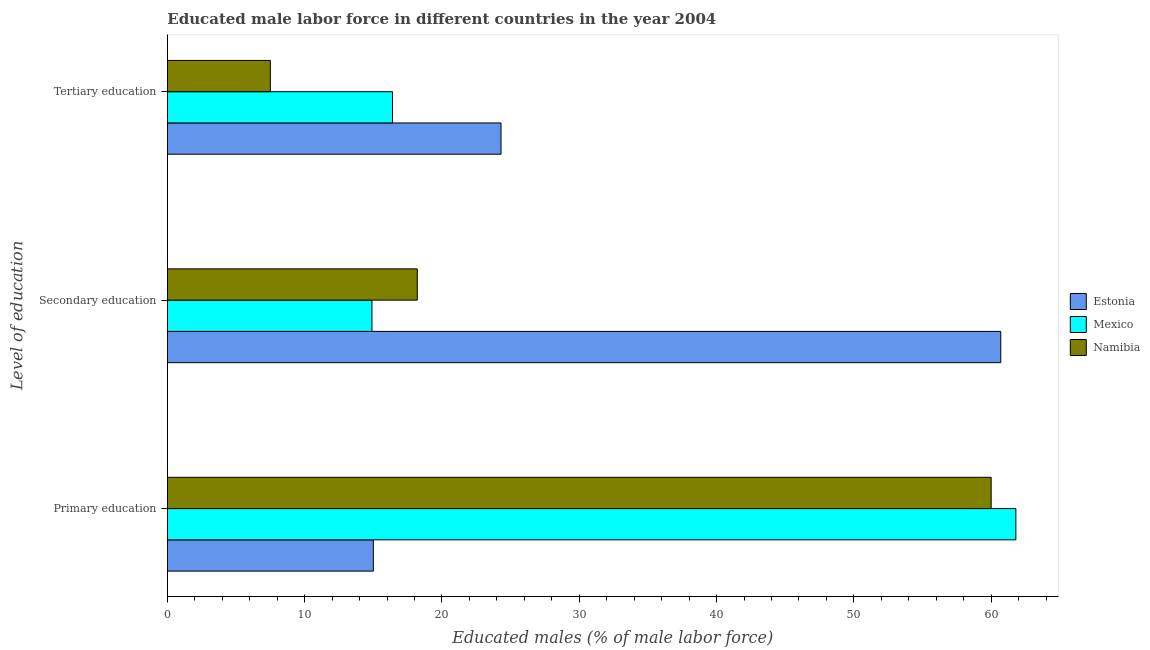Are the number of bars on each tick of the Y-axis equal?
Ensure brevity in your answer.  Yes. How many bars are there on the 3rd tick from the top?
Keep it short and to the point. 3. How many bars are there on the 1st tick from the bottom?
Offer a very short reply. 3. What is the label of the 1st group of bars from the top?
Give a very brief answer. Tertiary education. What is the percentage of male labor force who received secondary education in Estonia?
Make the answer very short. 60.7. Across all countries, what is the maximum percentage of male labor force who received tertiary education?
Offer a very short reply. 24.3. Across all countries, what is the minimum percentage of male labor force who received tertiary education?
Make the answer very short. 7.5. In which country was the percentage of male labor force who received tertiary education maximum?
Your answer should be compact. Estonia. In which country was the percentage of male labor force who received secondary education minimum?
Your answer should be compact. Mexico. What is the total percentage of male labor force who received tertiary education in the graph?
Ensure brevity in your answer.  48.2. What is the difference between the percentage of male labor force who received tertiary education in Estonia and that in Mexico?
Your response must be concise. 7.9. What is the difference between the percentage of male labor force who received primary education in Mexico and the percentage of male labor force who received tertiary education in Namibia?
Keep it short and to the point. 54.3. What is the average percentage of male labor force who received secondary education per country?
Give a very brief answer. 31.27. What is the difference between the percentage of male labor force who received tertiary education and percentage of male labor force who received secondary education in Namibia?
Your answer should be compact. -10.7. Is the percentage of male labor force who received primary education in Namibia less than that in Estonia?
Provide a short and direct response. No. Is the difference between the percentage of male labor force who received tertiary education in Mexico and Namibia greater than the difference between the percentage of male labor force who received primary education in Mexico and Namibia?
Offer a terse response. Yes. What is the difference between the highest and the second highest percentage of male labor force who received tertiary education?
Offer a terse response. 7.9. What is the difference between the highest and the lowest percentage of male labor force who received primary education?
Your answer should be very brief. 46.8. In how many countries, is the percentage of male labor force who received secondary education greater than the average percentage of male labor force who received secondary education taken over all countries?
Your answer should be very brief. 1. Is the sum of the percentage of male labor force who received primary education in Mexico and Estonia greater than the maximum percentage of male labor force who received secondary education across all countries?
Offer a very short reply. Yes. What does the 3rd bar from the top in Secondary education represents?
Provide a short and direct response. Estonia. How many countries are there in the graph?
Offer a terse response. 3. Are the values on the major ticks of X-axis written in scientific E-notation?
Your answer should be very brief. No. Does the graph contain any zero values?
Give a very brief answer. No. Does the graph contain grids?
Ensure brevity in your answer.  No. How are the legend labels stacked?
Provide a short and direct response. Vertical. What is the title of the graph?
Give a very brief answer. Educated male labor force in different countries in the year 2004. What is the label or title of the X-axis?
Your answer should be very brief. Educated males (% of male labor force). What is the label or title of the Y-axis?
Your answer should be very brief. Level of education. What is the Educated males (% of male labor force) of Mexico in Primary education?
Ensure brevity in your answer.  61.8. What is the Educated males (% of male labor force) in Estonia in Secondary education?
Your response must be concise. 60.7. What is the Educated males (% of male labor force) of Mexico in Secondary education?
Ensure brevity in your answer.  14.9. What is the Educated males (% of male labor force) in Namibia in Secondary education?
Give a very brief answer. 18.2. What is the Educated males (% of male labor force) in Estonia in Tertiary education?
Your response must be concise. 24.3. What is the Educated males (% of male labor force) in Mexico in Tertiary education?
Offer a terse response. 16.4. What is the Educated males (% of male labor force) of Namibia in Tertiary education?
Your response must be concise. 7.5. Across all Level of education, what is the maximum Educated males (% of male labor force) in Estonia?
Ensure brevity in your answer.  60.7. Across all Level of education, what is the maximum Educated males (% of male labor force) in Mexico?
Your answer should be very brief. 61.8. Across all Level of education, what is the minimum Educated males (% of male labor force) of Mexico?
Give a very brief answer. 14.9. What is the total Educated males (% of male labor force) in Mexico in the graph?
Offer a terse response. 93.1. What is the total Educated males (% of male labor force) in Namibia in the graph?
Your response must be concise. 85.7. What is the difference between the Educated males (% of male labor force) in Estonia in Primary education and that in Secondary education?
Your answer should be very brief. -45.7. What is the difference between the Educated males (% of male labor force) of Mexico in Primary education and that in Secondary education?
Provide a succinct answer. 46.9. What is the difference between the Educated males (% of male labor force) in Namibia in Primary education and that in Secondary education?
Provide a succinct answer. 41.8. What is the difference between the Educated males (% of male labor force) of Mexico in Primary education and that in Tertiary education?
Keep it short and to the point. 45.4. What is the difference between the Educated males (% of male labor force) of Namibia in Primary education and that in Tertiary education?
Your answer should be compact. 52.5. What is the difference between the Educated males (% of male labor force) of Estonia in Secondary education and that in Tertiary education?
Provide a succinct answer. 36.4. What is the difference between the Educated males (% of male labor force) of Mexico in Secondary education and that in Tertiary education?
Make the answer very short. -1.5. What is the difference between the Educated males (% of male labor force) of Namibia in Secondary education and that in Tertiary education?
Keep it short and to the point. 10.7. What is the difference between the Educated males (% of male labor force) in Estonia in Primary education and the Educated males (% of male labor force) in Mexico in Secondary education?
Your answer should be compact. 0.1. What is the difference between the Educated males (% of male labor force) in Estonia in Primary education and the Educated males (% of male labor force) in Namibia in Secondary education?
Offer a terse response. -3.2. What is the difference between the Educated males (% of male labor force) of Mexico in Primary education and the Educated males (% of male labor force) of Namibia in Secondary education?
Offer a very short reply. 43.6. What is the difference between the Educated males (% of male labor force) of Mexico in Primary education and the Educated males (% of male labor force) of Namibia in Tertiary education?
Your answer should be compact. 54.3. What is the difference between the Educated males (% of male labor force) in Estonia in Secondary education and the Educated males (% of male labor force) in Mexico in Tertiary education?
Your answer should be compact. 44.3. What is the difference between the Educated males (% of male labor force) of Estonia in Secondary education and the Educated males (% of male labor force) of Namibia in Tertiary education?
Provide a short and direct response. 53.2. What is the average Educated males (% of male labor force) of Estonia per Level of education?
Your answer should be compact. 33.33. What is the average Educated males (% of male labor force) of Mexico per Level of education?
Provide a succinct answer. 31.03. What is the average Educated males (% of male labor force) of Namibia per Level of education?
Make the answer very short. 28.57. What is the difference between the Educated males (% of male labor force) in Estonia and Educated males (% of male labor force) in Mexico in Primary education?
Provide a succinct answer. -46.8. What is the difference between the Educated males (% of male labor force) of Estonia and Educated males (% of male labor force) of Namibia in Primary education?
Make the answer very short. -45. What is the difference between the Educated males (% of male labor force) of Estonia and Educated males (% of male labor force) of Mexico in Secondary education?
Offer a terse response. 45.8. What is the difference between the Educated males (% of male labor force) of Estonia and Educated males (% of male labor force) of Namibia in Secondary education?
Your response must be concise. 42.5. What is the difference between the Educated males (% of male labor force) of Estonia and Educated males (% of male labor force) of Mexico in Tertiary education?
Make the answer very short. 7.9. What is the difference between the Educated males (% of male labor force) of Estonia and Educated males (% of male labor force) of Namibia in Tertiary education?
Ensure brevity in your answer.  16.8. What is the ratio of the Educated males (% of male labor force) of Estonia in Primary education to that in Secondary education?
Provide a succinct answer. 0.25. What is the ratio of the Educated males (% of male labor force) in Mexico in Primary education to that in Secondary education?
Your answer should be compact. 4.15. What is the ratio of the Educated males (% of male labor force) of Namibia in Primary education to that in Secondary education?
Ensure brevity in your answer.  3.3. What is the ratio of the Educated males (% of male labor force) in Estonia in Primary education to that in Tertiary education?
Ensure brevity in your answer.  0.62. What is the ratio of the Educated males (% of male labor force) in Mexico in Primary education to that in Tertiary education?
Offer a terse response. 3.77. What is the ratio of the Educated males (% of male labor force) in Estonia in Secondary education to that in Tertiary education?
Offer a terse response. 2.5. What is the ratio of the Educated males (% of male labor force) in Mexico in Secondary education to that in Tertiary education?
Your answer should be compact. 0.91. What is the ratio of the Educated males (% of male labor force) in Namibia in Secondary education to that in Tertiary education?
Your response must be concise. 2.43. What is the difference between the highest and the second highest Educated males (% of male labor force) of Estonia?
Give a very brief answer. 36.4. What is the difference between the highest and the second highest Educated males (% of male labor force) of Mexico?
Make the answer very short. 45.4. What is the difference between the highest and the second highest Educated males (% of male labor force) of Namibia?
Offer a very short reply. 41.8. What is the difference between the highest and the lowest Educated males (% of male labor force) of Estonia?
Provide a short and direct response. 45.7. What is the difference between the highest and the lowest Educated males (% of male labor force) of Mexico?
Your response must be concise. 46.9. What is the difference between the highest and the lowest Educated males (% of male labor force) of Namibia?
Give a very brief answer. 52.5. 